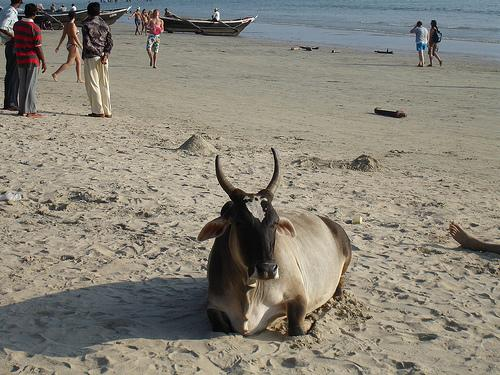Write a vivid description of the main animal in the image. A majestic horned cow reclines on the sun-kissed sand, its black face adorned with a white marking, seemingly surveying the lively beach scene around it. Write a short description of the scene with a focus on the animals present. A cow with distinct horns lounges on the sandy beach among beachgoers, boats, and a small sand pyramid. Describe the image in a simple and concise manner. A beach scene with a cow lying on the sand, people walking and engaging in various activities, and boats on the shore. Pick the most unusual element in the image and describe it. An intriguing sight on this beach is a horned cow, lying peacefully on the sand amidst the bustling beach scene. Describe the image in a poetic style. Upon the sandy shores where waves caress the land, a horned cow dreams, people wander, and boats lay still, amidst a dance of sunshine and serenade of the sea. Mention the object that is somewhat unique on this beach scene and its position. A small pyramid-shaped pile of sand stands amongst beachgoers and a lounging cow, adding an unexpected touch to the beach tableau. Detail the clothing and actions of the people in the image. People on the beach wear diverse outfits, such as striped shirts, white pants, swim trunks, and bikinis, while they walk, stand, or hold a frisbee. Narrate the scene as if you are present in the image and describing it to a friend. Hey, you won't believe this! There's a cow with huge horns just chilling on the sand! People are walking, boats are on the shore, and there's even a small sand pyramid! Provide a brief summary of the image capturing the key elements. A horned cow lies on the sand, people walk along the water's edge, and boats rest nearby as other individuals enjoy various beach activities. Highlight the main activities people are doing on this beach scene. Beachgoers walk near the ocean, stand in the sand, and partake in leisurely activities such as holding a frisbee or wearing a bikini. 